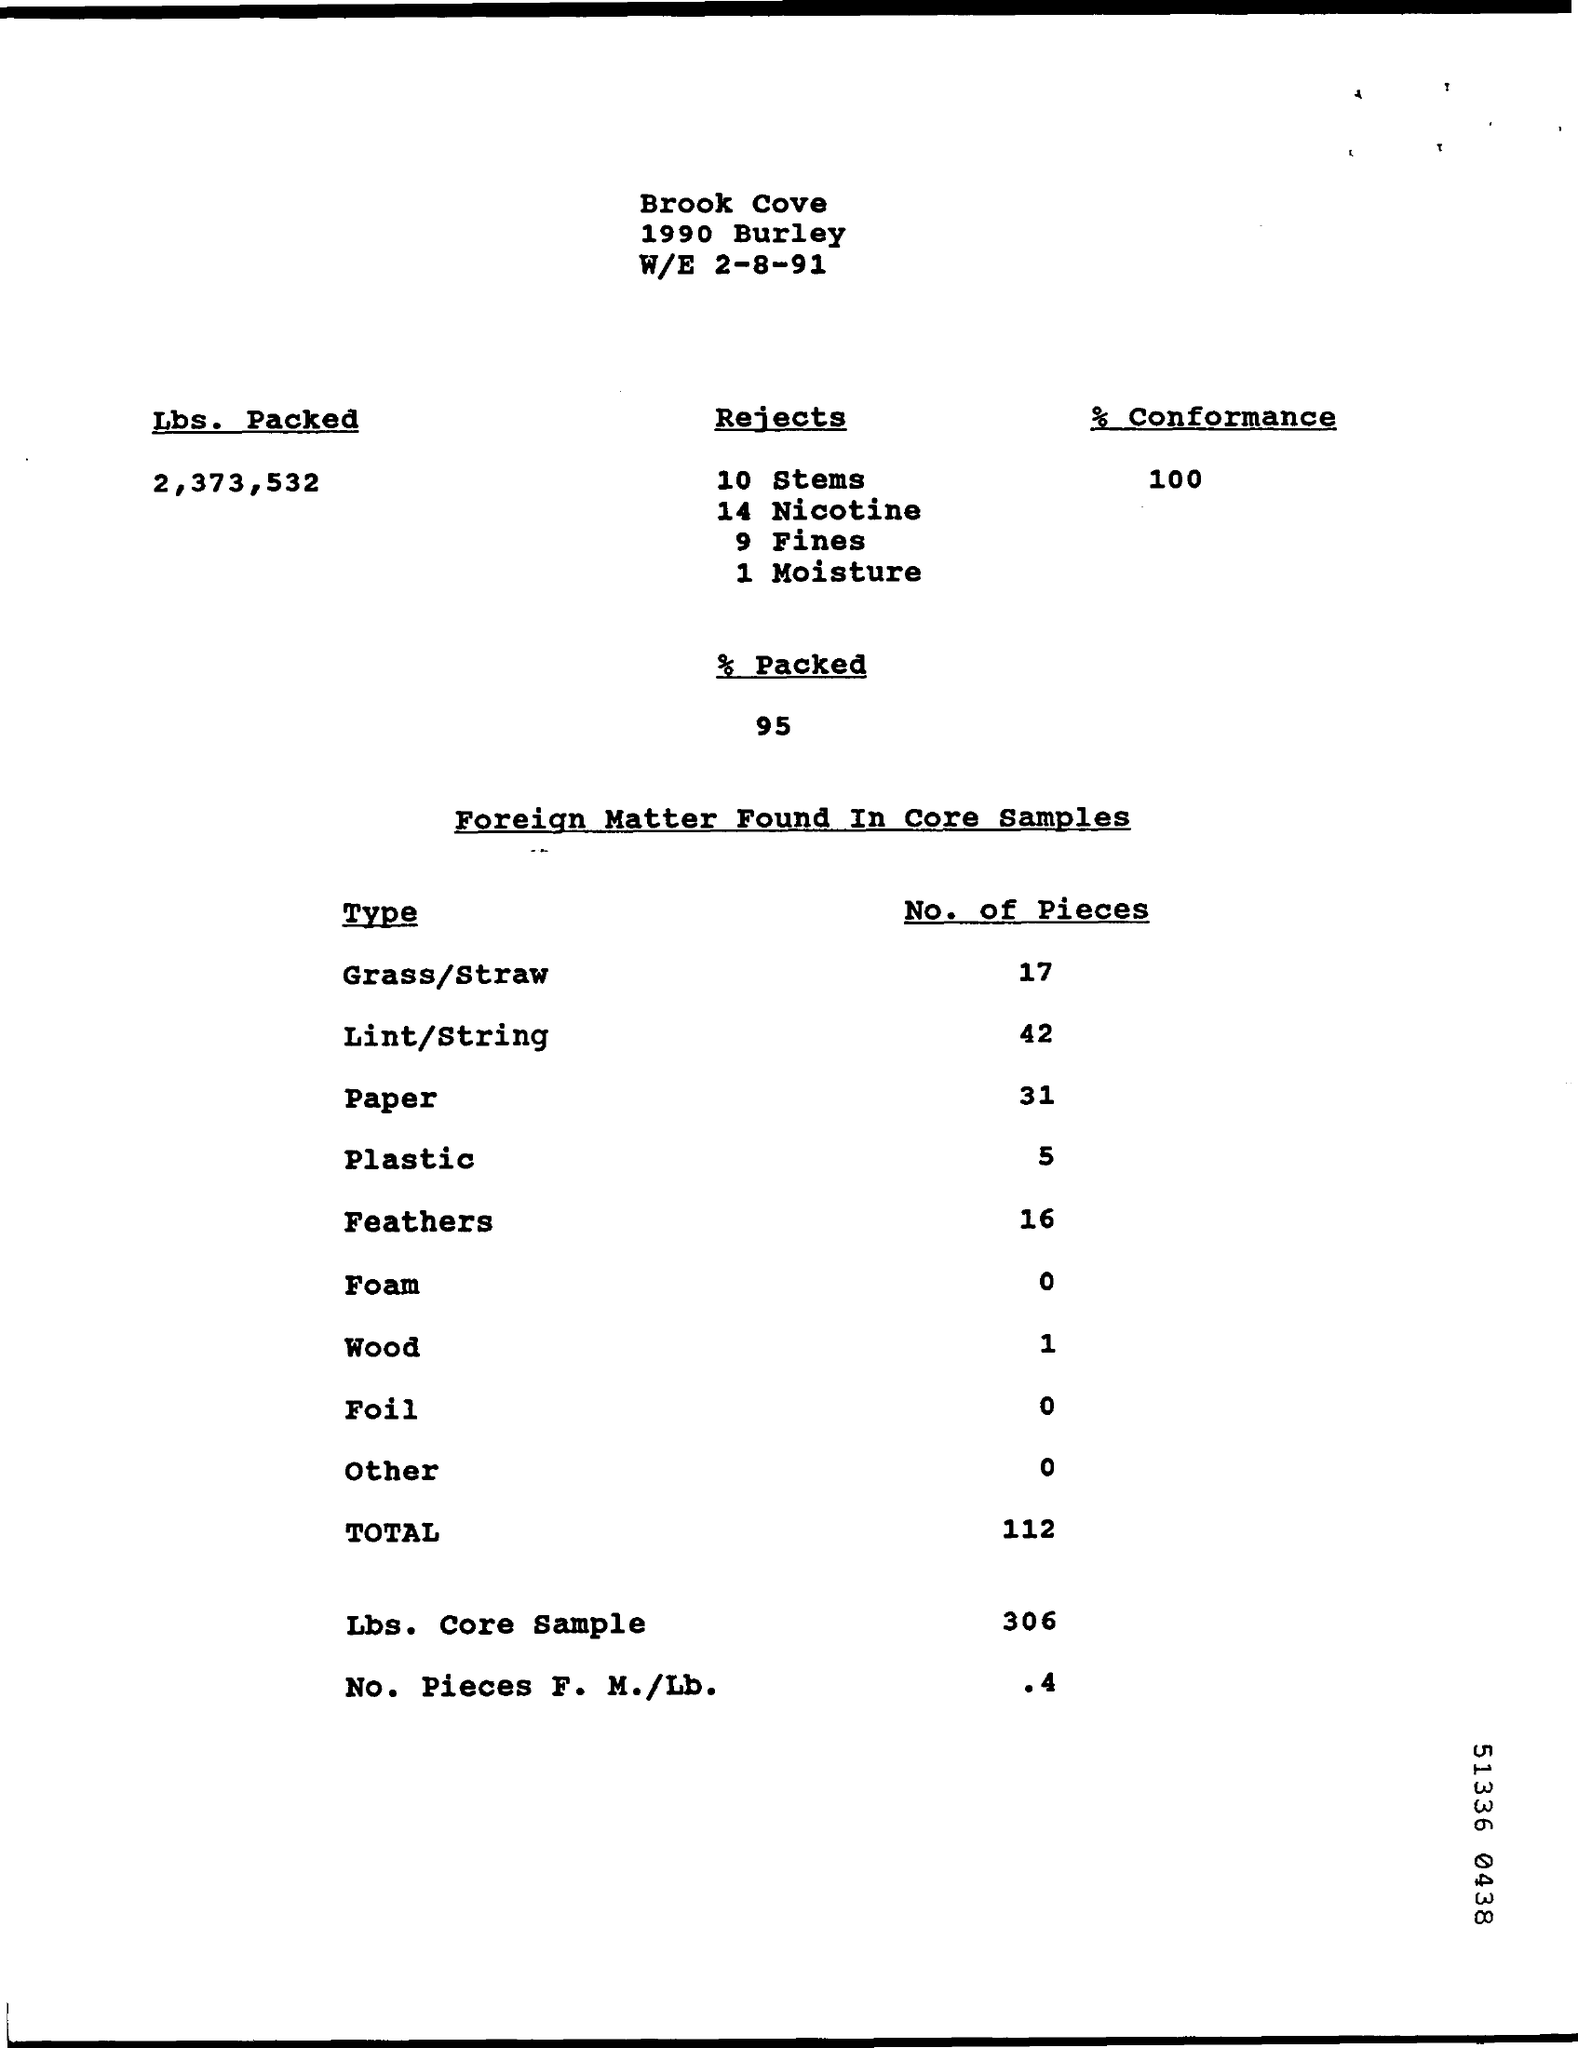What is the percentage of conformance?
Provide a succinct answer. 100. How many fines were rejected?
Your answer should be very brief. 9. How many pieces of lint/string were found?
Provide a short and direct response. 42. What percentage was packed?
Your answer should be compact. 95. 